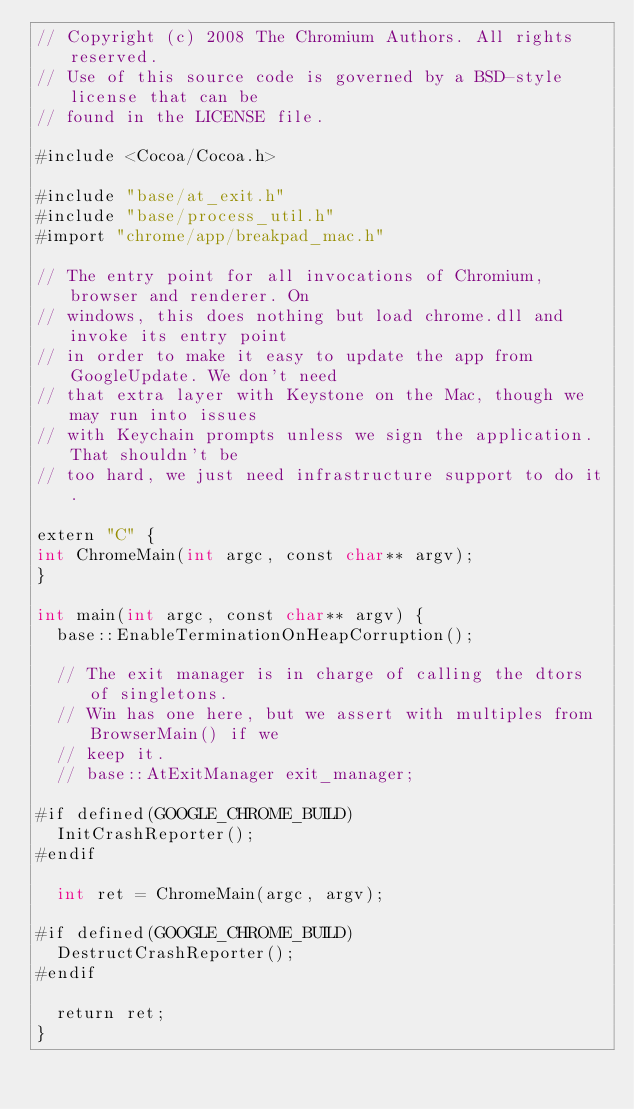<code> <loc_0><loc_0><loc_500><loc_500><_ObjectiveC_>// Copyright (c) 2008 The Chromium Authors. All rights reserved.
// Use of this source code is governed by a BSD-style license that can be
// found in the LICENSE file.

#include <Cocoa/Cocoa.h>

#include "base/at_exit.h"
#include "base/process_util.h"
#import "chrome/app/breakpad_mac.h"

// The entry point for all invocations of Chromium, browser and renderer. On
// windows, this does nothing but load chrome.dll and invoke its entry point
// in order to make it easy to update the app from GoogleUpdate. We don't need
// that extra layer with Keystone on the Mac, though we may run into issues
// with Keychain prompts unless we sign the application. That shouldn't be
// too hard, we just need infrastructure support to do it.

extern "C" {
int ChromeMain(int argc, const char** argv);
}

int main(int argc, const char** argv) {
  base::EnableTerminationOnHeapCorruption();

  // The exit manager is in charge of calling the dtors of singletons.
  // Win has one here, but we assert with multiples from BrowserMain() if we
  // keep it.
  // base::AtExitManager exit_manager;

#if defined(GOOGLE_CHROME_BUILD)
  InitCrashReporter();
#endif

  int ret = ChromeMain(argc, argv);

#if defined(GOOGLE_CHROME_BUILD)
  DestructCrashReporter();
#endif

  return ret;
}
</code> 